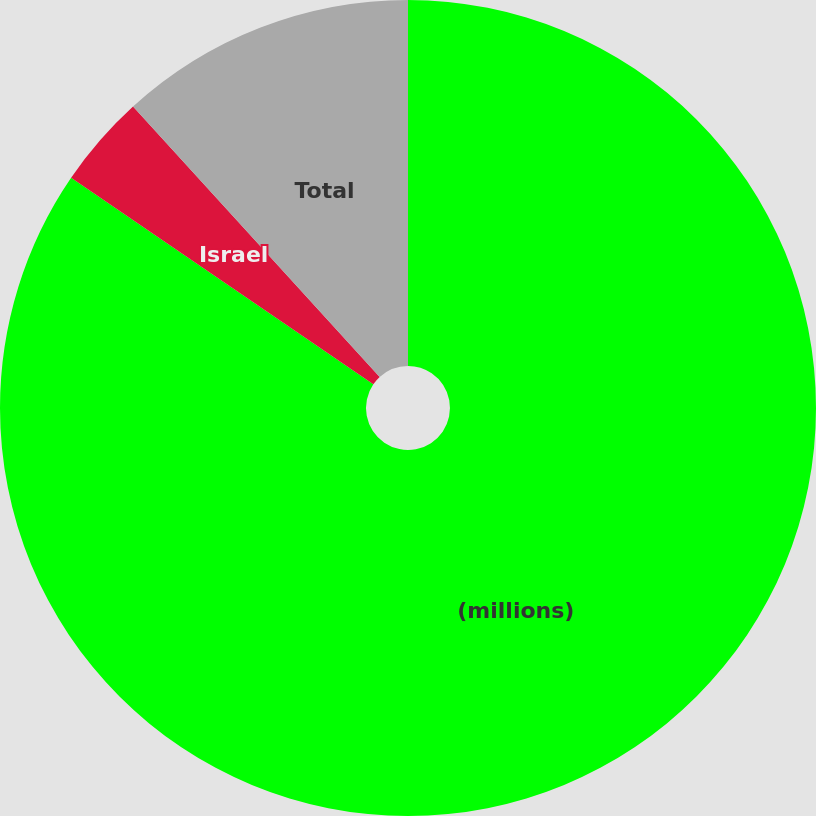Convert chart to OTSL. <chart><loc_0><loc_0><loc_500><loc_500><pie_chart><fcel>(millions)<fcel>Israel<fcel>Total<nl><fcel>84.54%<fcel>3.69%<fcel>11.77%<nl></chart> 